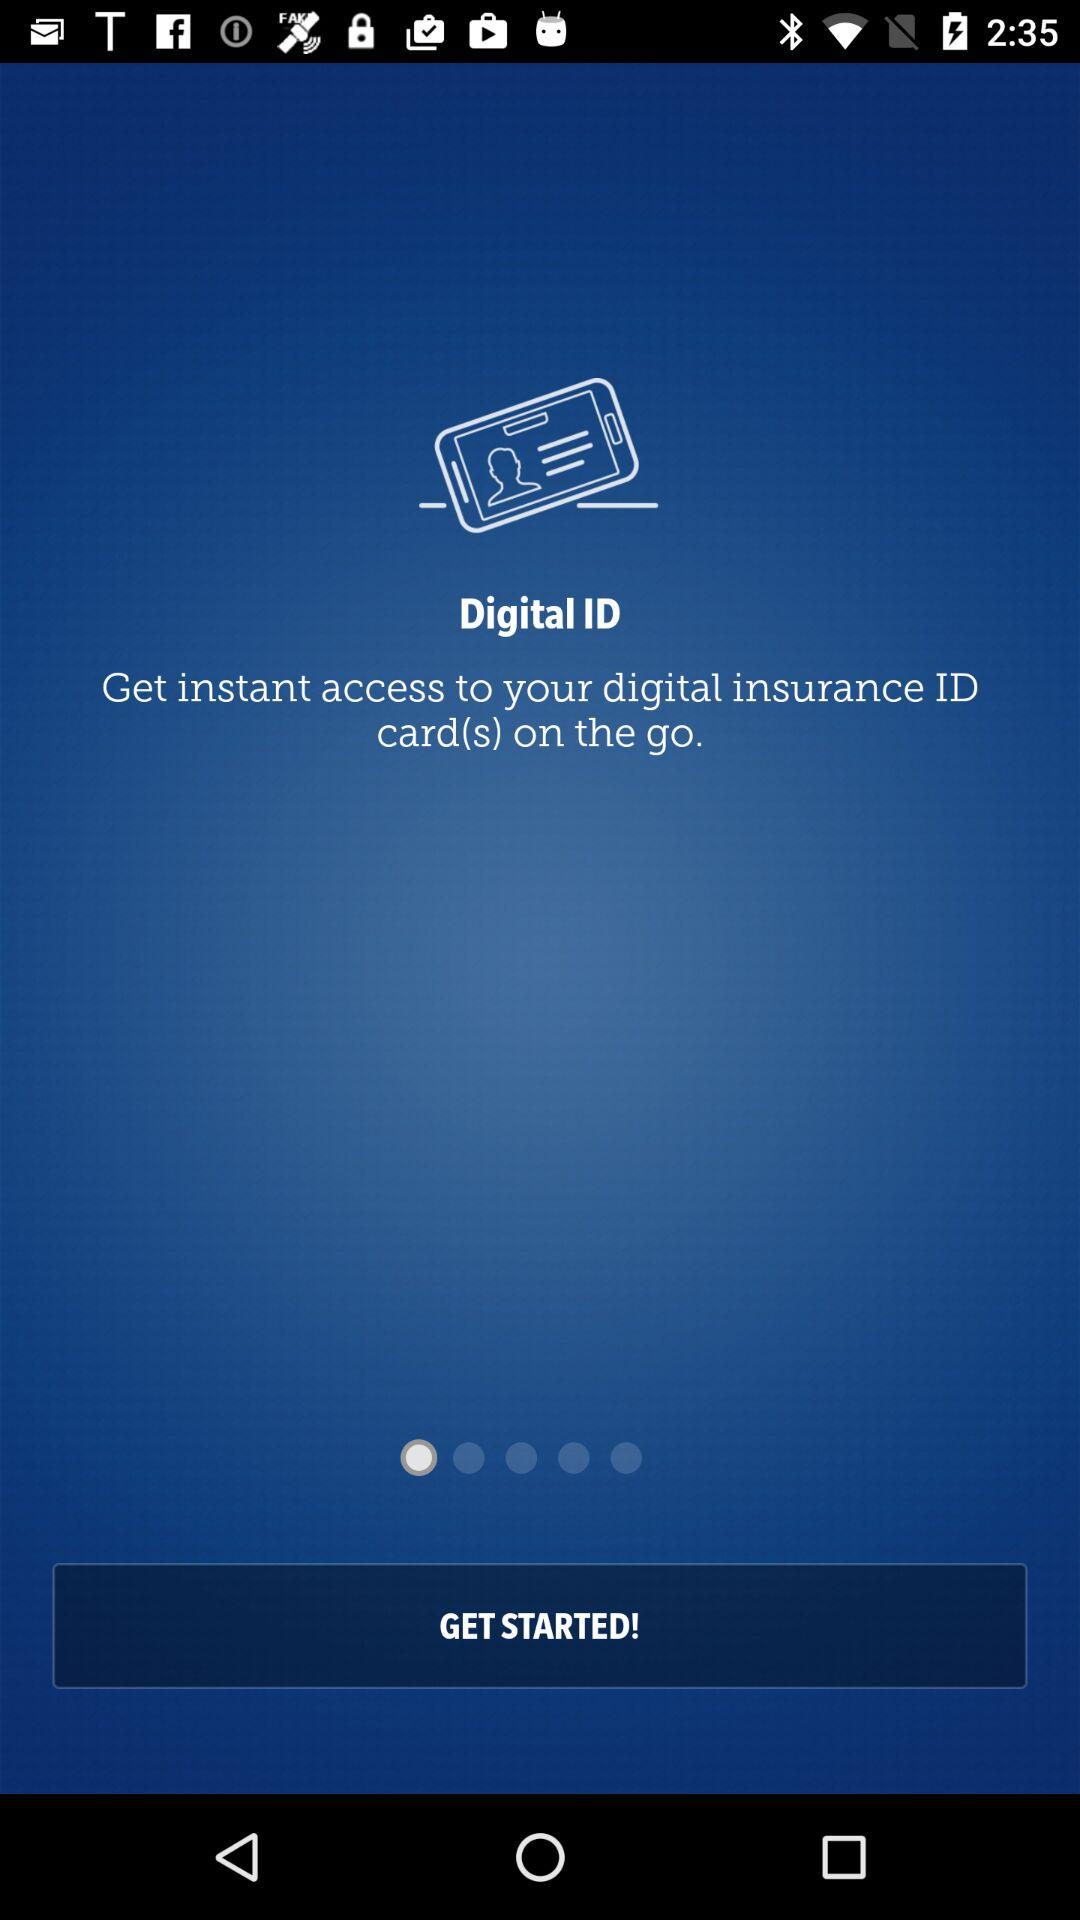What is the app name? The app name is "Digital ID". 